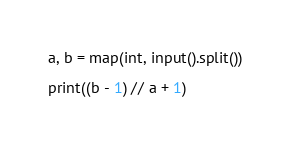Convert code to text. <code><loc_0><loc_0><loc_500><loc_500><_Python_>a, b = map(int, input().split())

print((b - 1) // a + 1)
</code> 